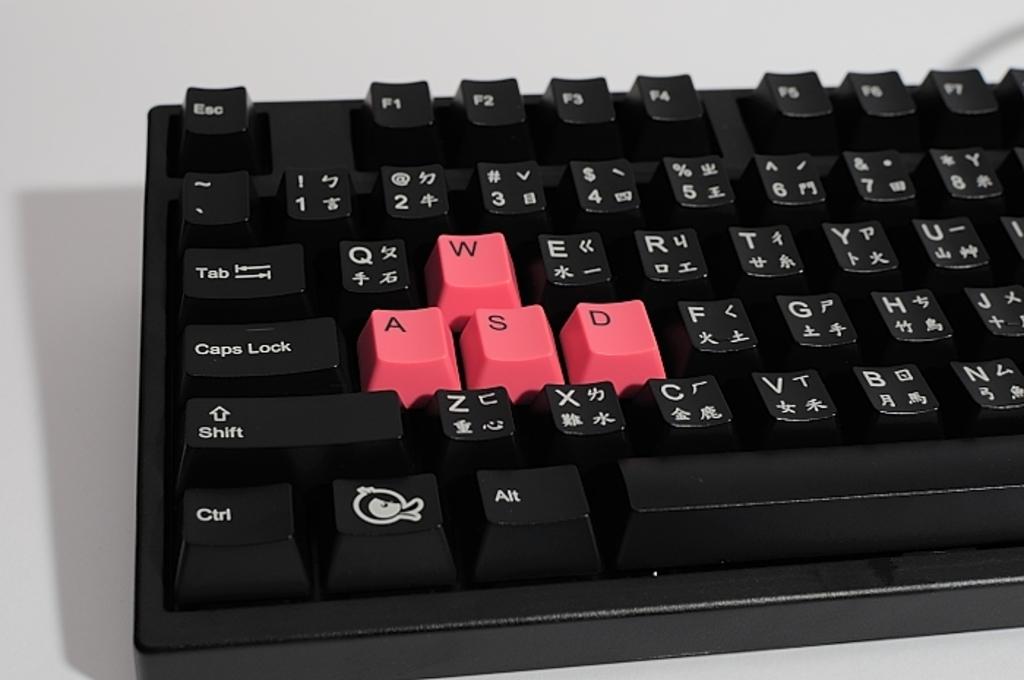What keys are pink?
Keep it short and to the point. Wasd. What keys are black?
Your response must be concise. Esc f1 f2 f3 f4 f5 f6 f7 ` 1 2 3 4 5 6 7 8 tab q e r t y u i capslock f g h j shift z x c v b n ctrl meta alt spacebar. 